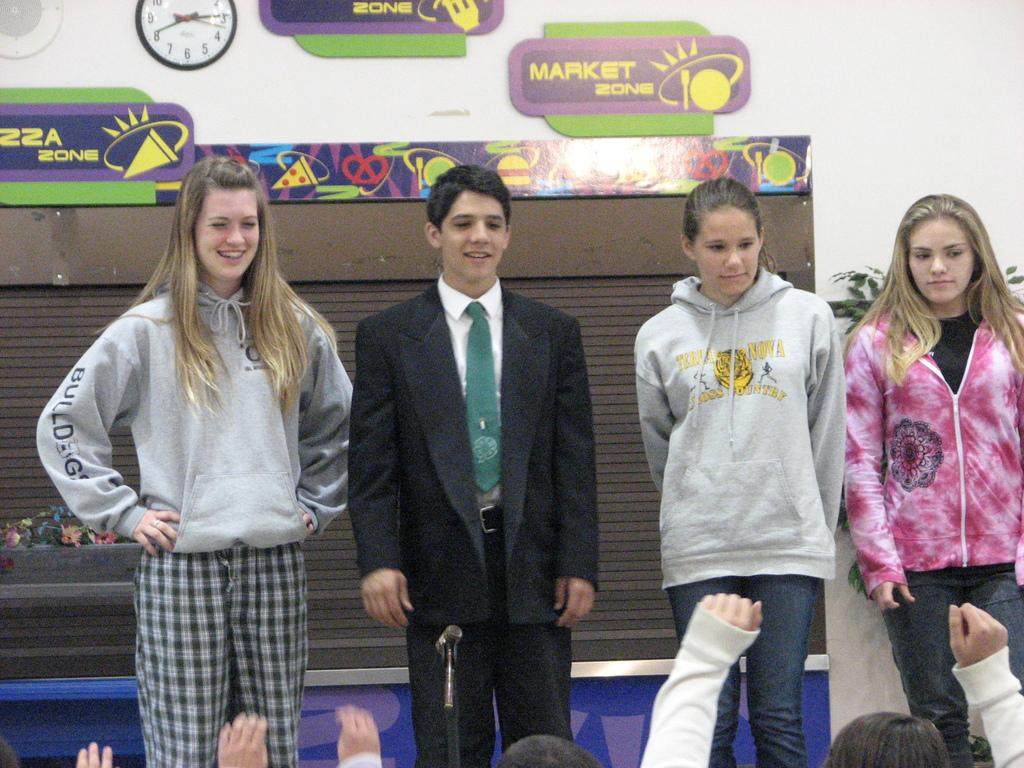What can be seen in the image? There are people standing in the image. Where are the people located in the image? The people are at the bottom of the image. What object is present in the image that displays time? There is a clock in the image. What can be found on the wall in the image? There are boards with text on the wall in the image. What type of government is depicted in the image? There is no depiction of a government in the image; it features people standing, a clock, and boards with text on the wall. How many sisters are present in the image? There is no mention of sisters in the image; it only shows people standing, a clock, and boards with text on the wall. 